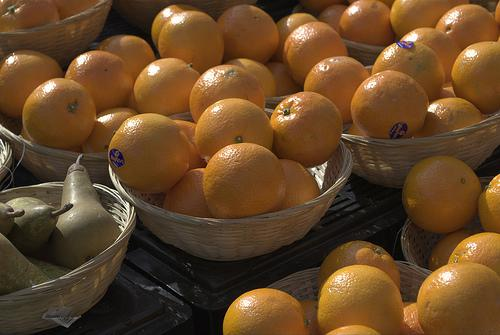Question: what are the oranges in?
Choices:
A. Bowls.
B. Baskets.
C. Bags.
D. Boxes.
Answer with the letter. Answer: B Question: where are the oranges?
Choices:
A. In boxes.
B. In crates.
C. In brown paper bags.
D. Baskets.
Answer with the letter. Answer: D Question: what is on the table?
Choices:
A. Vegetables.
B. Bread.
C. Milk.
D. Fruits.
Answer with the letter. Answer: D Question: how many fruits?
Choices:
A. 3.
B. 4.
C. 2.
D. 5.
Answer with the letter. Answer: C 